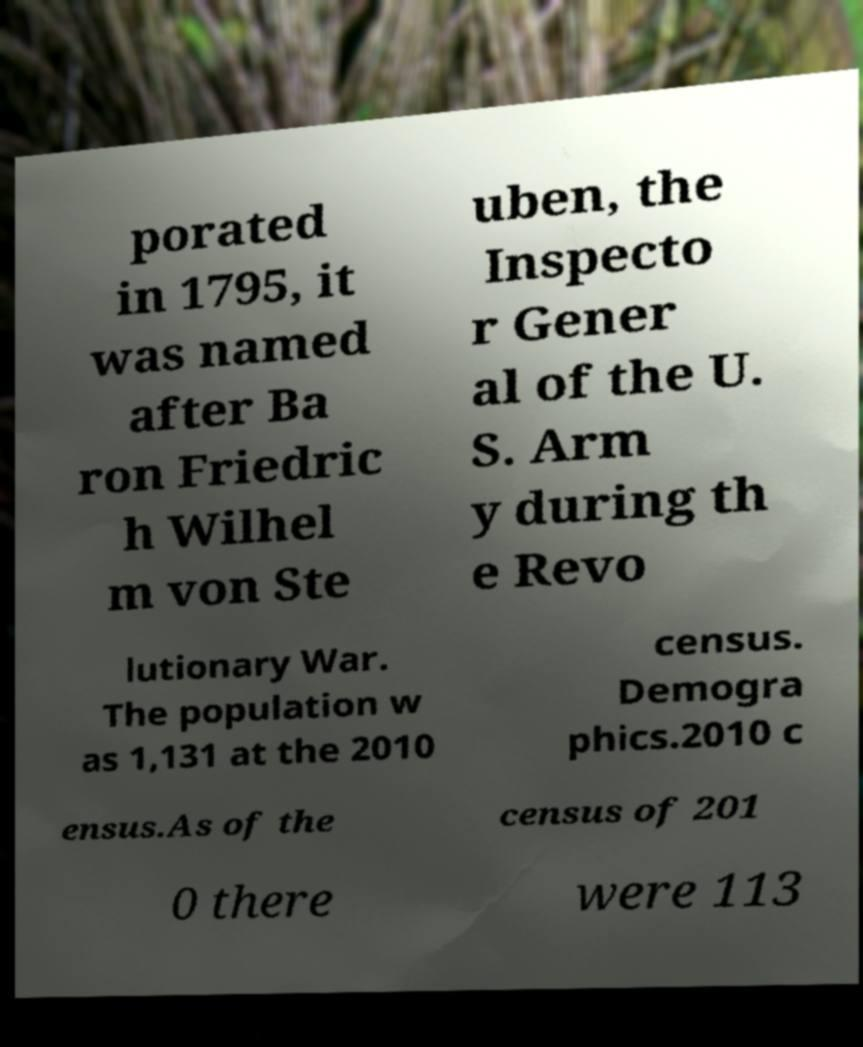Please read and relay the text visible in this image. What does it say? porated in 1795, it was named after Ba ron Friedric h Wilhel m von Ste uben, the Inspecto r Gener al of the U. S. Arm y during th e Revo lutionary War. The population w as 1,131 at the 2010 census. Demogra phics.2010 c ensus.As of the census of 201 0 there were 113 